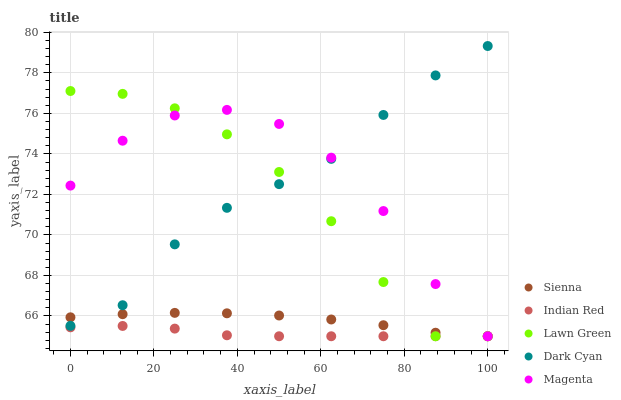Does Indian Red have the minimum area under the curve?
Answer yes or no. Yes. Does Magenta have the maximum area under the curve?
Answer yes or no. Yes. Does Lawn Green have the minimum area under the curve?
Answer yes or no. No. Does Lawn Green have the maximum area under the curve?
Answer yes or no. No. Is Sienna the smoothest?
Answer yes or no. Yes. Is Magenta the roughest?
Answer yes or no. Yes. Is Lawn Green the smoothest?
Answer yes or no. No. Is Lawn Green the roughest?
Answer yes or no. No. Does Sienna have the lowest value?
Answer yes or no. Yes. Does Dark Cyan have the lowest value?
Answer yes or no. No. Does Dark Cyan have the highest value?
Answer yes or no. Yes. Does Lawn Green have the highest value?
Answer yes or no. No. Is Indian Red less than Dark Cyan?
Answer yes or no. Yes. Is Dark Cyan greater than Indian Red?
Answer yes or no. Yes. Does Sienna intersect Lawn Green?
Answer yes or no. Yes. Is Sienna less than Lawn Green?
Answer yes or no. No. Is Sienna greater than Lawn Green?
Answer yes or no. No. Does Indian Red intersect Dark Cyan?
Answer yes or no. No. 